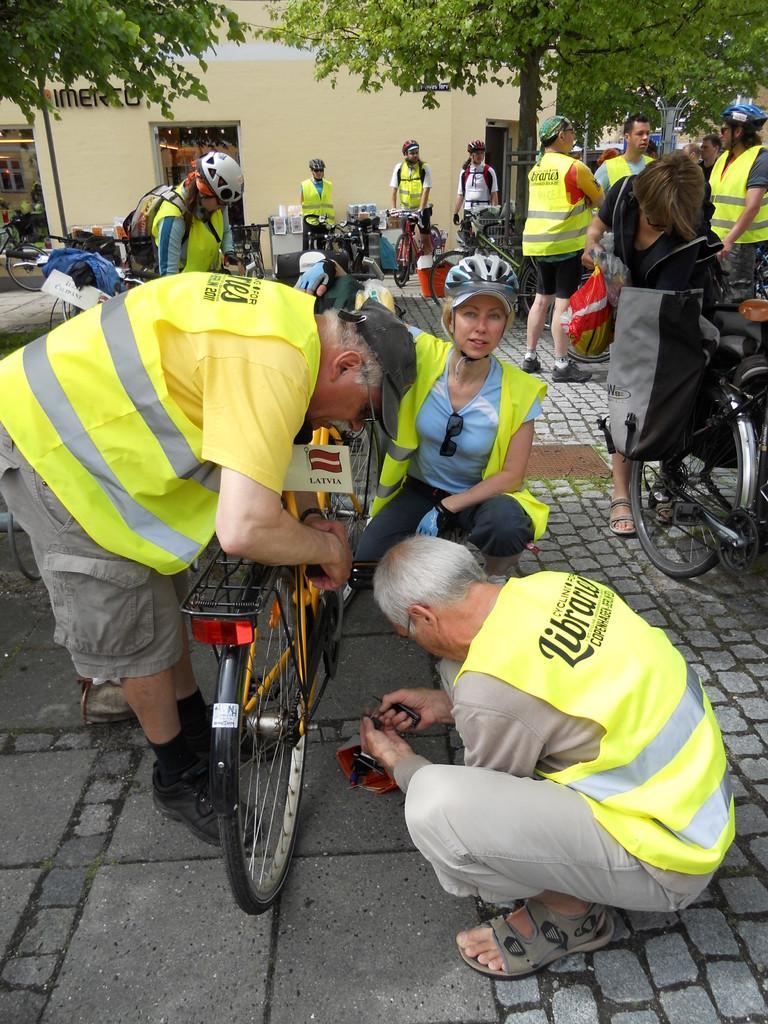Can you describe this image briefly? In this picture we can see bicycles and a group of people on the road were some of them wore helmets, jackets and in the background we can see trees, building with a name on it and some objects. 